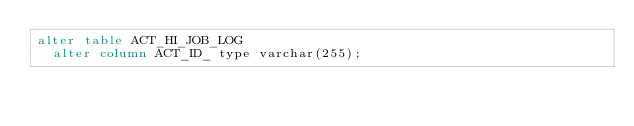<code> <loc_0><loc_0><loc_500><loc_500><_SQL_>alter table ACT_HI_JOB_LOG
  alter column ACT_ID_ type varchar(255);</code> 